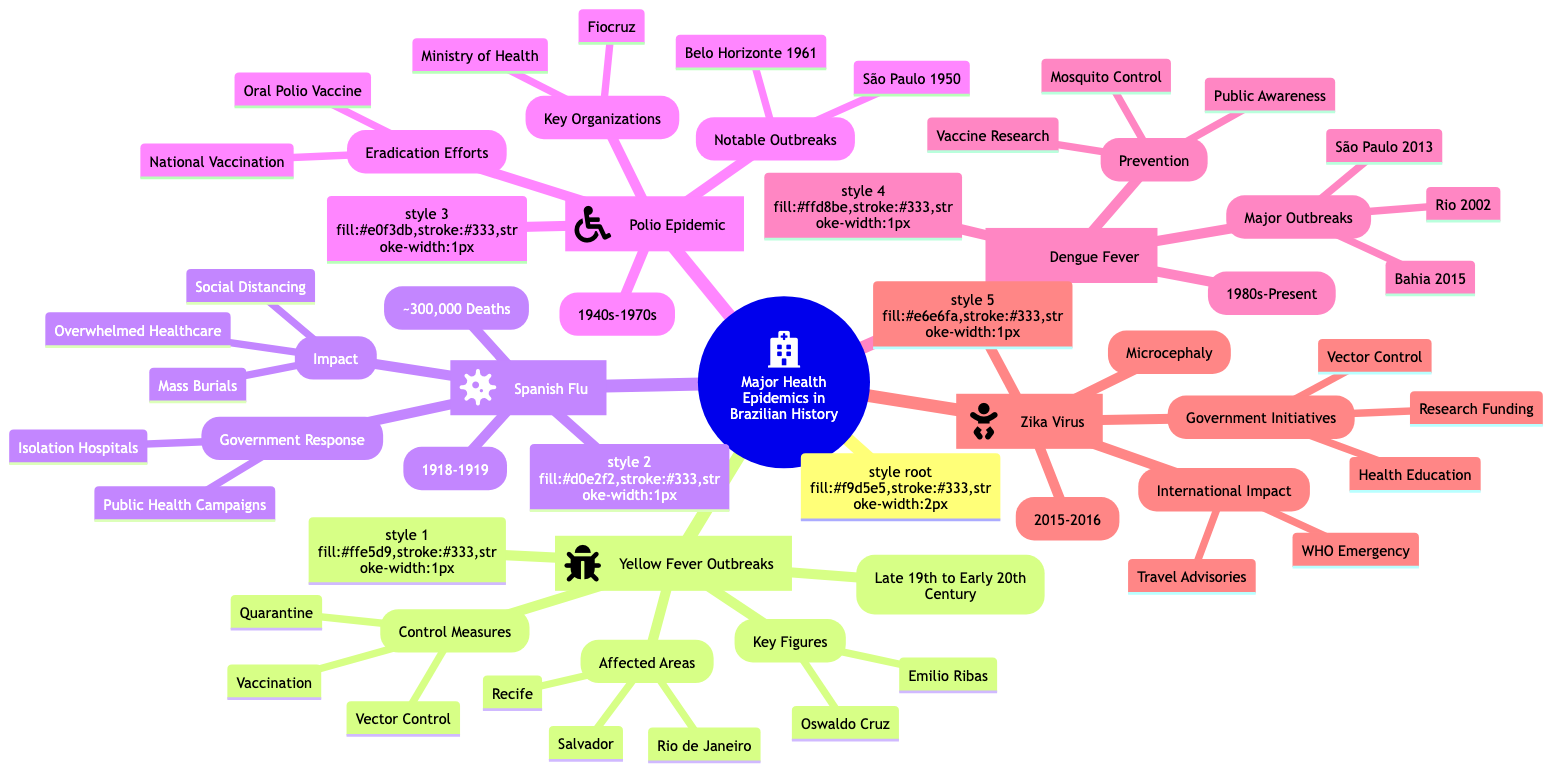What time period did the Yellow Fever outbreaks occur? The diagram specifies that Yellow Fever outbreaks occurred in the "Late 19th to Early 20th Century." This information can be found in the section labeled "Yellow Fever Outbreaks."
Answer: Late 19th to Early 20th Century Which cities were affected by Yellow Fever? The diagram lists "Rio de Janeiro," "Recife," and "Salvador" as the affected areas of the Yellow Fever outbreaks. These cities are located in the corresponding node.
Answer: Rio de Janeiro, Recife, Salvador How many estimated deaths were attributed to the Spanish Flu in Brazil? According to the diagram, the Spanish Flu resulted in approximately "300,000" deaths. This number is mentioned in the section for the Spanish Flu specifically.
Answer: 300,000 What was a government response to the Spanish Flu outbreak? The diagram indicates "Public Health Campaigns" and the "Establishment of Isolation Hospitals" as government responses. Hence, either phrase serves as an accurate answer.
Answer: Public Health Campaigns Which key organization was involved in the Polio Epidemic eradication efforts? The diagram mentions "Fundação Oswaldo Cruz (Fiocruz)" as one of the key organizations involved in Polio eradication efforts. This information is part of the "Key Organizations" section under "Polio Epidemic."
Answer: Fundação Oswaldo Cruz (Fiocruz) What major health initiative was taken during the Zika Virus outbreak? The diagram highlights "Vector Control Initiatives," "Research Funding for Vaccine," and "Public Health Education" as initiatives. Therefore, any of these three answers would be correct.
Answer: Vector Control Initiatives How does the timeline for Dengue Fever outbreaks compare to the other epidemics? Dengue Fever is noted as ongoing from "1980s to Present," which indicates a longer duration compared to the other epidemics, each of which has distinct and shorter timeframes in the diagram.
Answer: 1980s-Present Which years did the significant outbreaks of Dengue Fever occur? The diagram lists specific major outbreaks in "Rio de Janeiro (2002)," "São Paulo (2013)," and "Bahia (2015)." This information highlights the timeline for the major outbreaks of Dengue Fever.
Answer: Rio de Janeiro (2002), São Paulo (2013), Bahia (2015) What was a significant societal impact of the Spanish Flu? The diagram describes several impacts, such as "Overwhelmed Healthcare System," "Mass Burials," and "Social Distancing Measures." Any of these phrases could serve as an appropriate answer.
Answer: Overwhelmed Healthcare System 